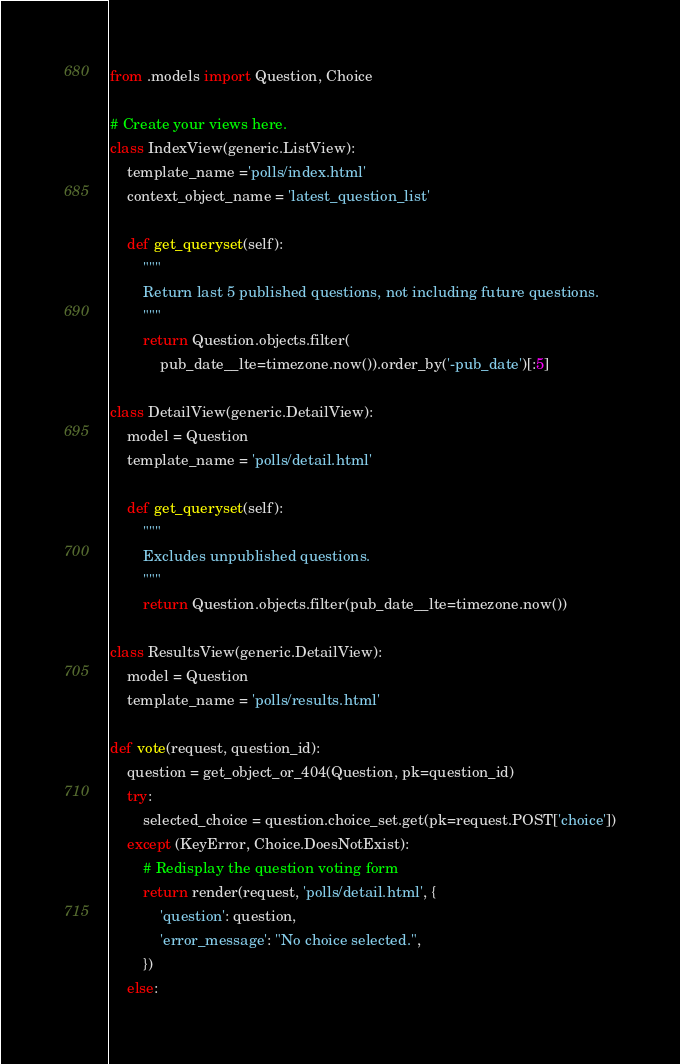Convert code to text. <code><loc_0><loc_0><loc_500><loc_500><_Python_>from .models import Question, Choice

# Create your views here.
class IndexView(generic.ListView):
    template_name ='polls/index.html'
    context_object_name = 'latest_question_list'

    def get_queryset(self):
        """
        Return last 5 published questions, not including future questions.
        """
        return Question.objects.filter(
            pub_date__lte=timezone.now()).order_by('-pub_date')[:5]

class DetailView(generic.DetailView):
    model = Question
    template_name = 'polls/detail.html'

    def get_queryset(self):
        """
        Excludes unpublished questions.
        """
        return Question.objects.filter(pub_date__lte=timezone.now())

class ResultsView(generic.DetailView):
    model = Question
    template_name = 'polls/results.html'

def vote(request, question_id):
    question = get_object_or_404(Question, pk=question_id)
    try:
        selected_choice = question.choice_set.get(pk=request.POST['choice'])
    except (KeyError, Choice.DoesNotExist):
        # Redisplay the question voting form
        return render(request, 'polls/detail.html', {
            'question': question,
            'error_message': "No choice selected.",
        })
    else:</code> 